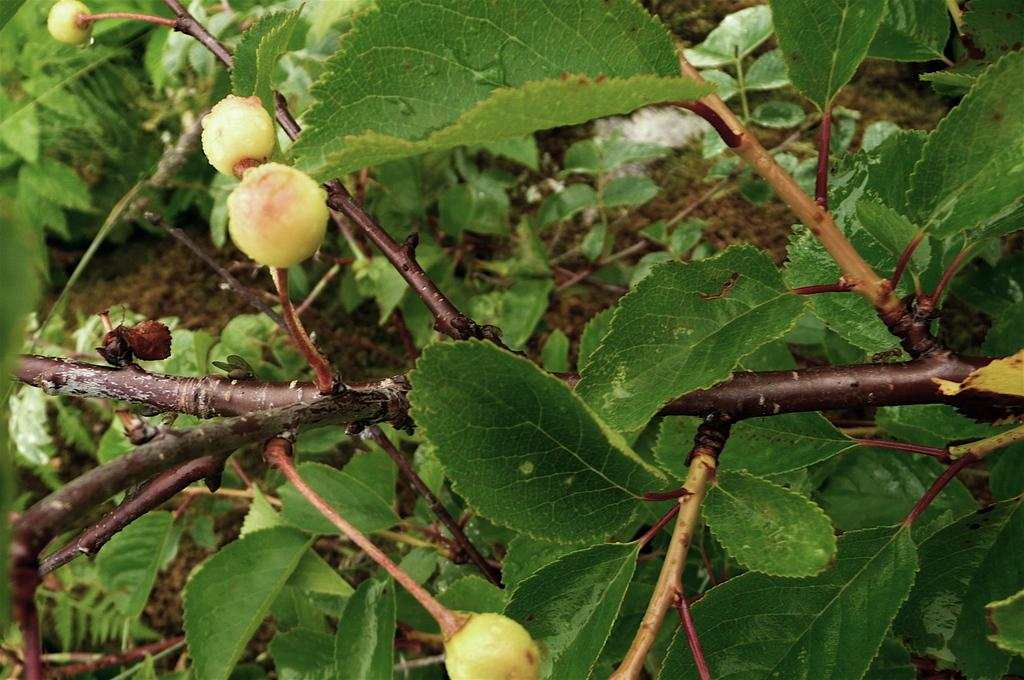What type of food items can be seen in the image? There are fruits in the image. What color are the leaves that are visible in the image? The leaves in the image are green. How are the leaves connected to the plant? The leaves are attached to a stem. What can be seen at the bottom of the image? There is mud visible at the bottom of the image. Can you tell me how the fruits are being guided by the yoke in the image? There is no yoke present in the image, and therefore no guidance of fruits can be observed. 